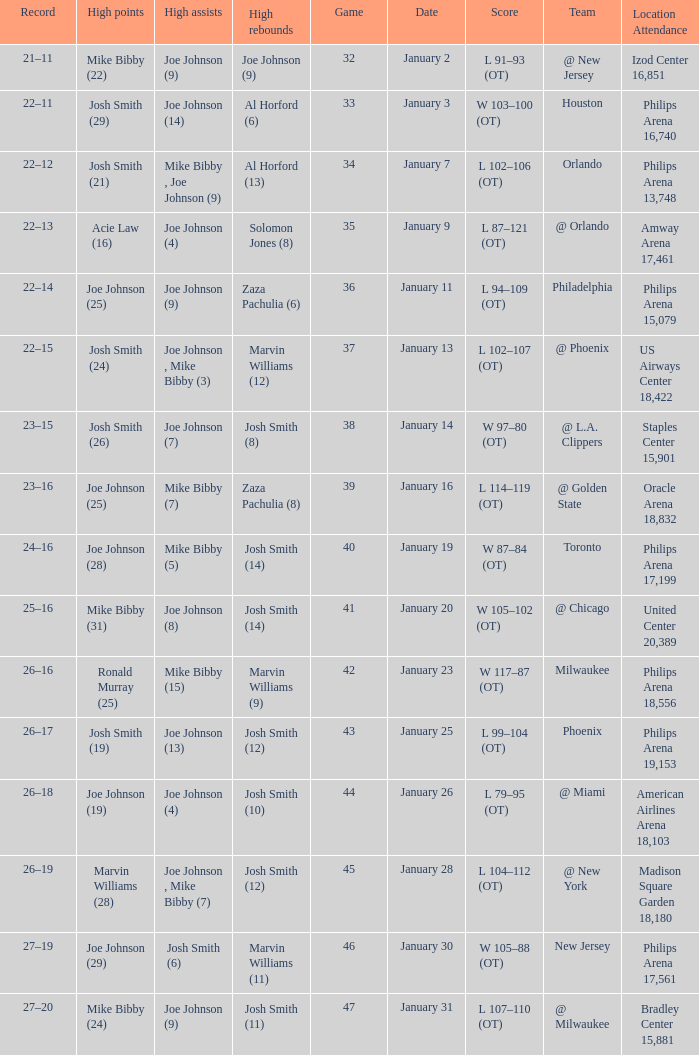What was the record after game 37? 22–15. 